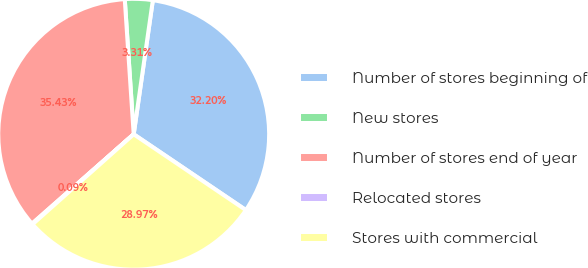Convert chart to OTSL. <chart><loc_0><loc_0><loc_500><loc_500><pie_chart><fcel>Number of stores beginning of<fcel>New stores<fcel>Number of stores end of year<fcel>Relocated stores<fcel>Stores with commercial<nl><fcel>32.2%<fcel>3.31%<fcel>35.43%<fcel>0.09%<fcel>28.97%<nl></chart> 